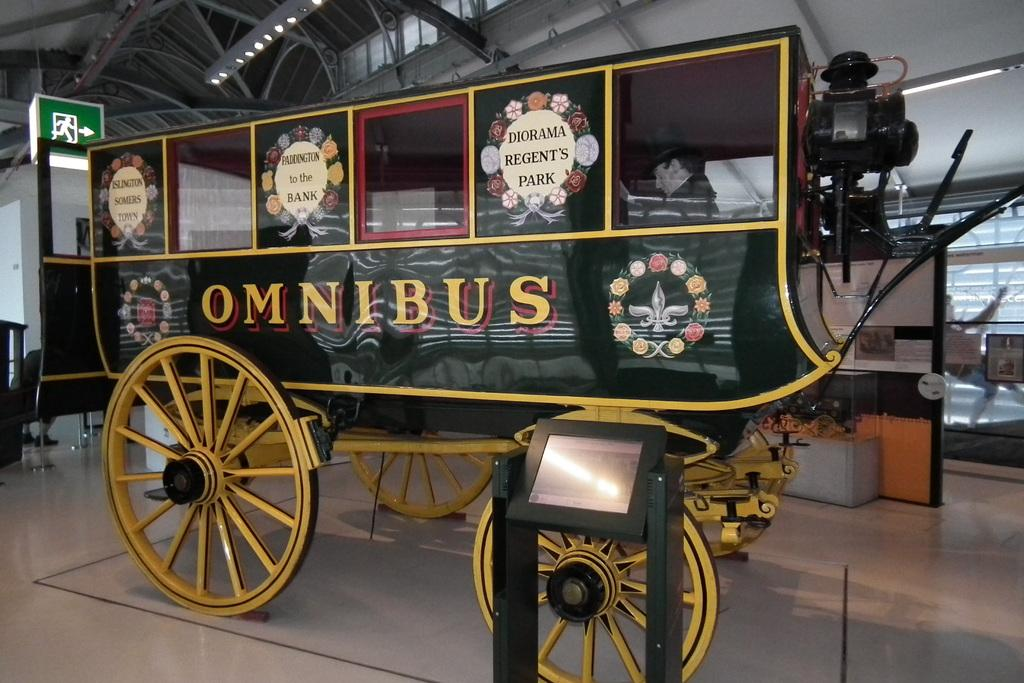What is the main subject in the center of the image? There is a vehicle in the center of the image. What is located at the bottom of the image? There is a monitor at the bottom of the image. What can be seen in the background of the image? There are iron bars, a sign board, and a wall in the background of the image. How many owls are sitting on the vehicle in the image? There are no owls present in the image. What type of books can be seen on the sign board in the image? There are no books visible on the sign board in the image. 